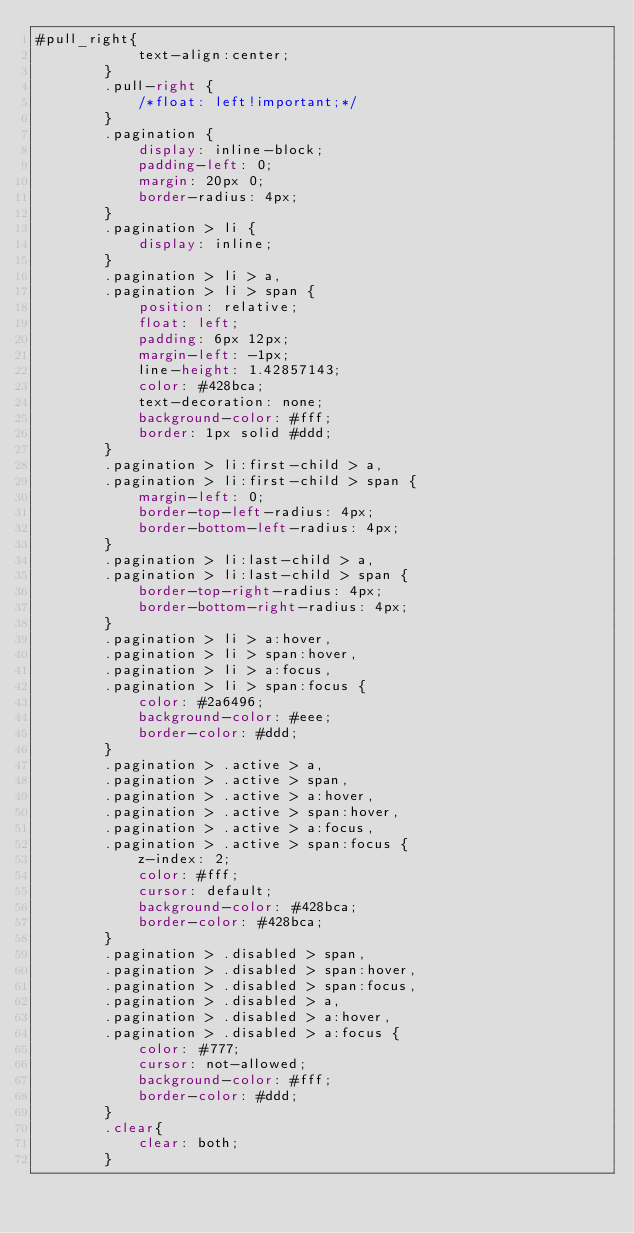Convert code to text. <code><loc_0><loc_0><loc_500><loc_500><_CSS_>#pull_right{
            text-align:center;
        }
        .pull-right {
            /*float: left!important;*/
        }
        .pagination {
            display: inline-block;
            padding-left: 0;
            margin: 20px 0;
            border-radius: 4px;
        }
        .pagination > li {
            display: inline;
        }
        .pagination > li > a,
        .pagination > li > span {
            position: relative;
            float: left;
            padding: 6px 12px;
            margin-left: -1px;
            line-height: 1.42857143;
            color: #428bca;
            text-decoration: none;
            background-color: #fff;
            border: 1px solid #ddd;
        }
        .pagination > li:first-child > a,
        .pagination > li:first-child > span {
            margin-left: 0;
            border-top-left-radius: 4px;
            border-bottom-left-radius: 4px;
        }
        .pagination > li:last-child > a,
        .pagination > li:last-child > span {
            border-top-right-radius: 4px;
            border-bottom-right-radius: 4px;
        }
        .pagination > li > a:hover,
        .pagination > li > span:hover,
        .pagination > li > a:focus,
        .pagination > li > span:focus {
            color: #2a6496;
            background-color: #eee;
            border-color: #ddd;
        }
        .pagination > .active > a,
        .pagination > .active > span,
        .pagination > .active > a:hover,
        .pagination > .active > span:hover,
        .pagination > .active > a:focus,
        .pagination > .active > span:focus {
            z-index: 2;
            color: #fff;
            cursor: default;
            background-color: #428bca;
            border-color: #428bca;
        }
        .pagination > .disabled > span,
        .pagination > .disabled > span:hover,
        .pagination > .disabled > span:focus,
        .pagination > .disabled > a,
        .pagination > .disabled > a:hover,
        .pagination > .disabled > a:focus {
            color: #777;
            cursor: not-allowed;
            background-color: #fff;
            border-color: #ddd;
        }
        .clear{
            clear: both;
        }</code> 